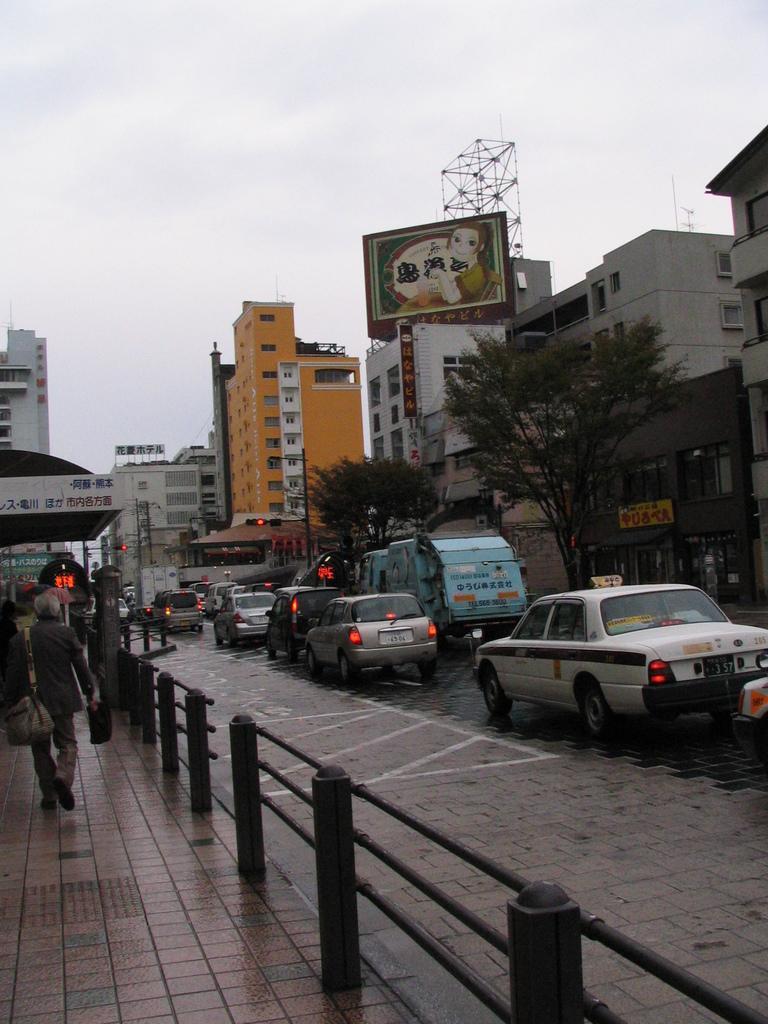Can you describe this image briefly? This is an outside view. On the right side there are some vehicles on the road. On the left side I can see few people are walking on the footpath. Beside the footpath there is a railing. In the background there are many buildings and trees. At the top of the image I can see the sky. 